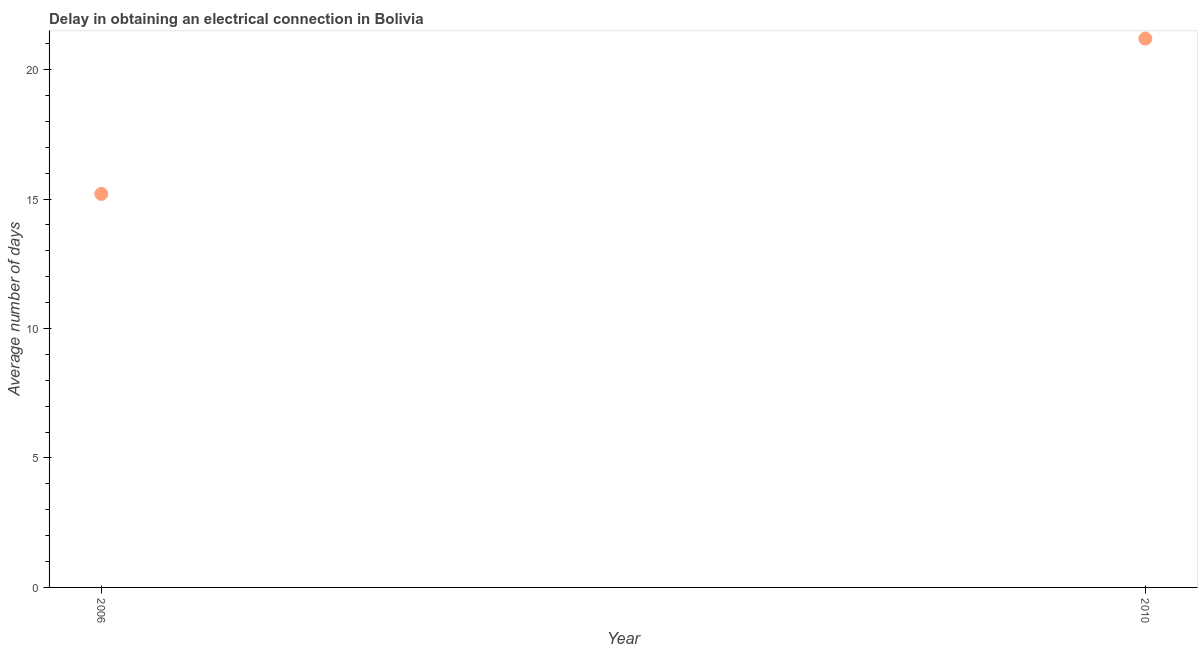What is the dalay in electrical connection in 2010?
Provide a short and direct response. 21.2. Across all years, what is the maximum dalay in electrical connection?
Your response must be concise. 21.2. In which year was the dalay in electrical connection minimum?
Offer a terse response. 2006. What is the sum of the dalay in electrical connection?
Keep it short and to the point. 36.4. What is the difference between the dalay in electrical connection in 2006 and 2010?
Make the answer very short. -6. In how many years, is the dalay in electrical connection greater than 3 days?
Your answer should be very brief. 2. Do a majority of the years between 2006 and 2010 (inclusive) have dalay in electrical connection greater than 15 days?
Your answer should be compact. Yes. What is the ratio of the dalay in electrical connection in 2006 to that in 2010?
Keep it short and to the point. 0.72. In how many years, is the dalay in electrical connection greater than the average dalay in electrical connection taken over all years?
Make the answer very short. 1. Does the dalay in electrical connection monotonically increase over the years?
Give a very brief answer. Yes. How many years are there in the graph?
Give a very brief answer. 2. Does the graph contain any zero values?
Your answer should be very brief. No. Does the graph contain grids?
Your response must be concise. No. What is the title of the graph?
Ensure brevity in your answer.  Delay in obtaining an electrical connection in Bolivia. What is the label or title of the Y-axis?
Make the answer very short. Average number of days. What is the Average number of days in 2006?
Offer a terse response. 15.2. What is the Average number of days in 2010?
Make the answer very short. 21.2. What is the ratio of the Average number of days in 2006 to that in 2010?
Provide a short and direct response. 0.72. 